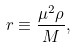Convert formula to latex. <formula><loc_0><loc_0><loc_500><loc_500>r \equiv \frac { \mu ^ { 2 } \rho } { M } ,</formula> 